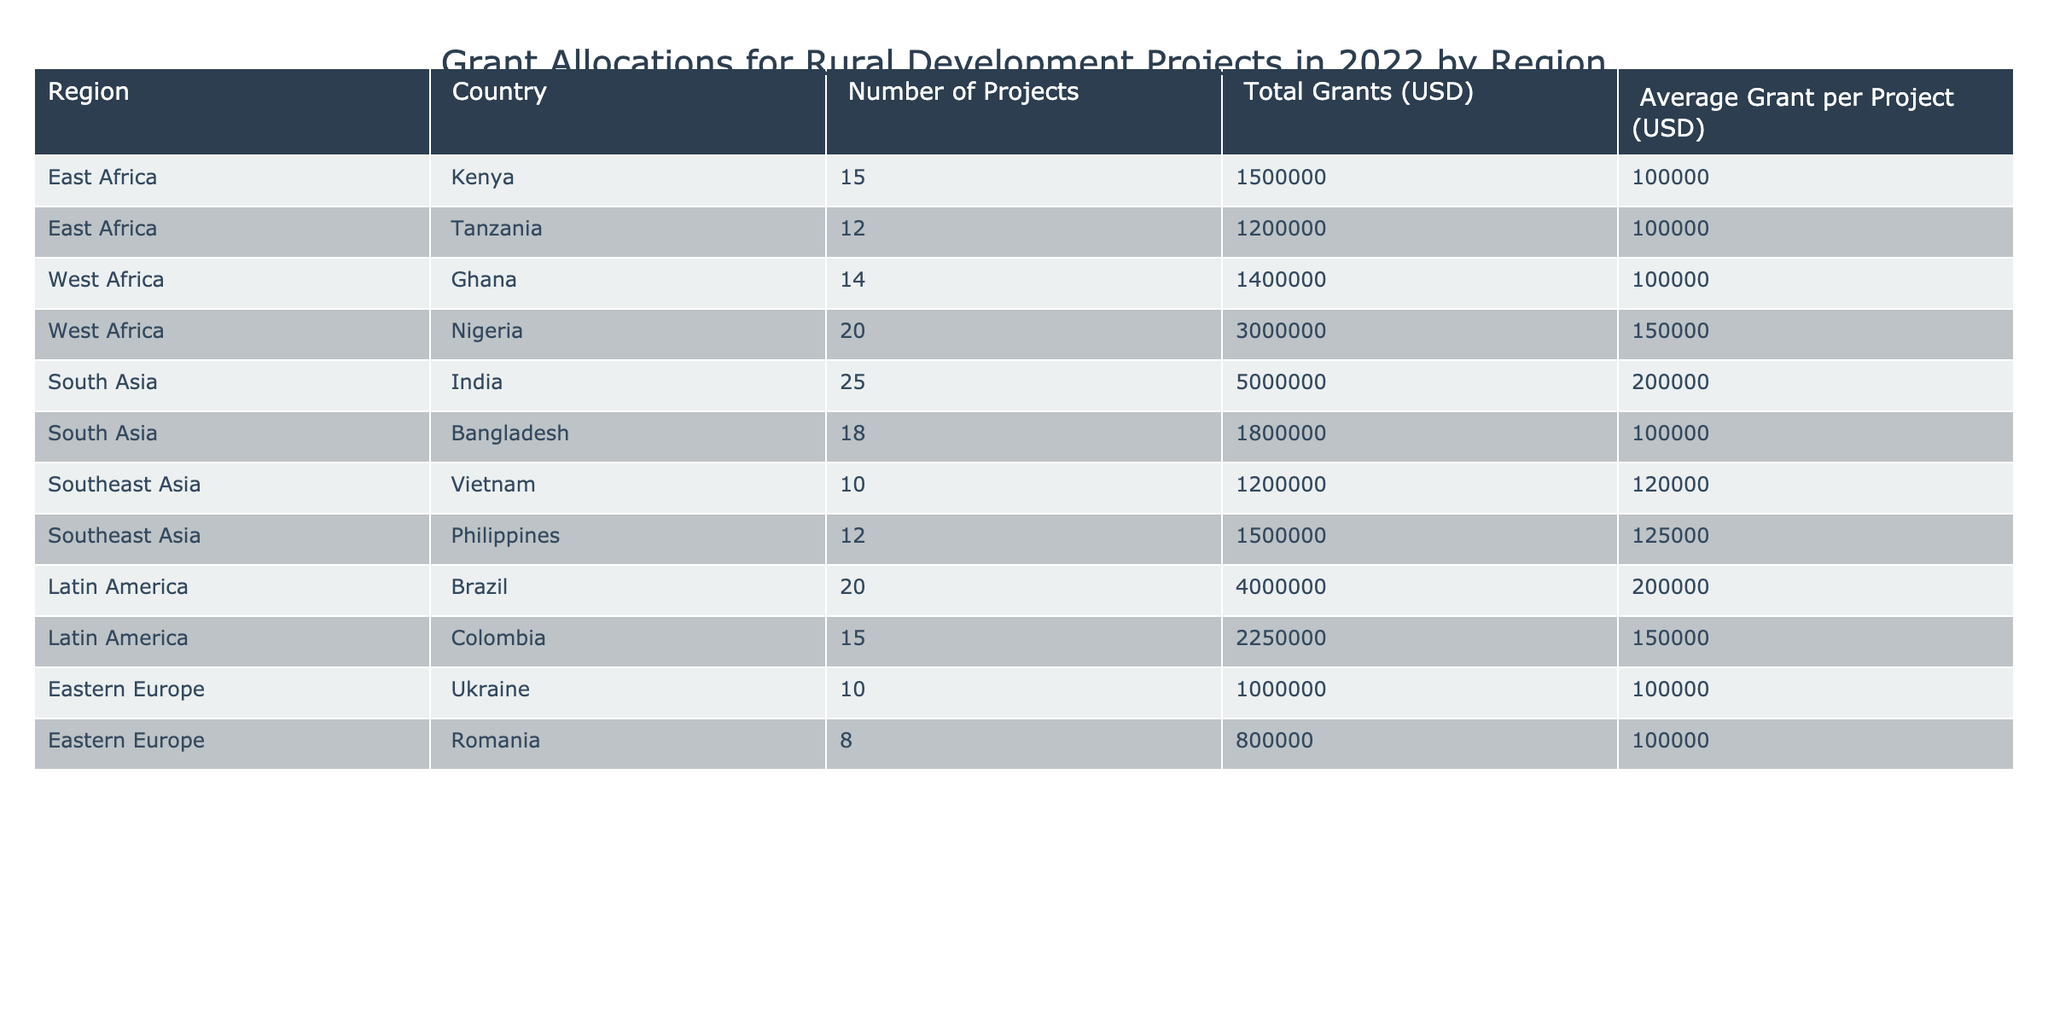What region has the highest total grants allocated? By examining the "Total Grants (USD)" column, the highest value is 5000000, which corresponds to South Asia, specifically India with 25 projects. Therefore, South Asia is the region with the highest total grants.
Answer: South Asia Which country received the lowest average grant per project? To find the lowest average, we look at the "Average Grant per Project (USD)" column. The lowest value is 100000, which corresponds to Kenya, Tanzania, Ghana, and Ukraine. Therefore, these countries received the lowest average grants per project.
Answer: Kenya, Tanzania, Ghana, Ukraine How many total projects were funded in West Africa? We sum the "Number of Projects" for Ghana (14) and Nigeria (20) to get the total number of projects in West Africa: 14 + 20 = 34.
Answer: 34 Is the average grant per project higher in South Asia than in Southeast Asia? To determine this, we compare the average grants: South Asia has an average of 200000 (India, Bangladesh) and Southeast Asia has an average of (120000 (Vietnam) + 125000 (Philippines)) / 2 = 122500. Since 200000 is greater than 122500, the statement is true.
Answer: Yes Which region has the highest average grant per project? By calculating the average for each region: South Asia (200000), East Africa (100000), West Africa (150000), Southeast Asia (122500), Latin America (200000), Eastern Europe (100000). South Asia and Latin America both have the highest average grant per project at 200000.
Answer: South Asia, Latin America What is the total grant amount for projects in Latin America? We can find this in the "Total Grants (USD)” column for Brazil (4000000) and Colombia (2250000). The total is 4000000 + 2250000 = 6250000.
Answer: 6250000 Is there a country that has projects with both the highest number and the highest total grants? Upon checking, Nigeria has the highest number of projects (20) and the highest total grants allocated (3000000) compared to other countries in the table. This makes the answer true.
Answer: Yes What is the difference in total grants between the highest and lowest country grants? The highest grant is from India at 5000000 and the lowest from Romania at 800000. The difference is 5000000 - 800000 = 4200000.
Answer: 4200000 